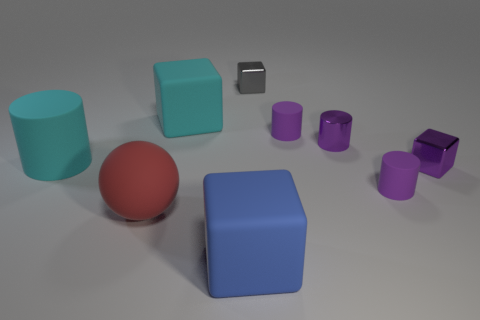Do the block that is to the left of the large blue rubber cube and the large matte block in front of the metallic cylinder have the same color? Despite both items appearing similar at first glance, their colors are not identical. The block to the left of the large blue rubber cube exhibits a distinct turquoise shade, while the large matte block positioned in front of the metallic cylinder is a shade of lilac. This subtle difference in hue means the two blocks do not share the same color. 